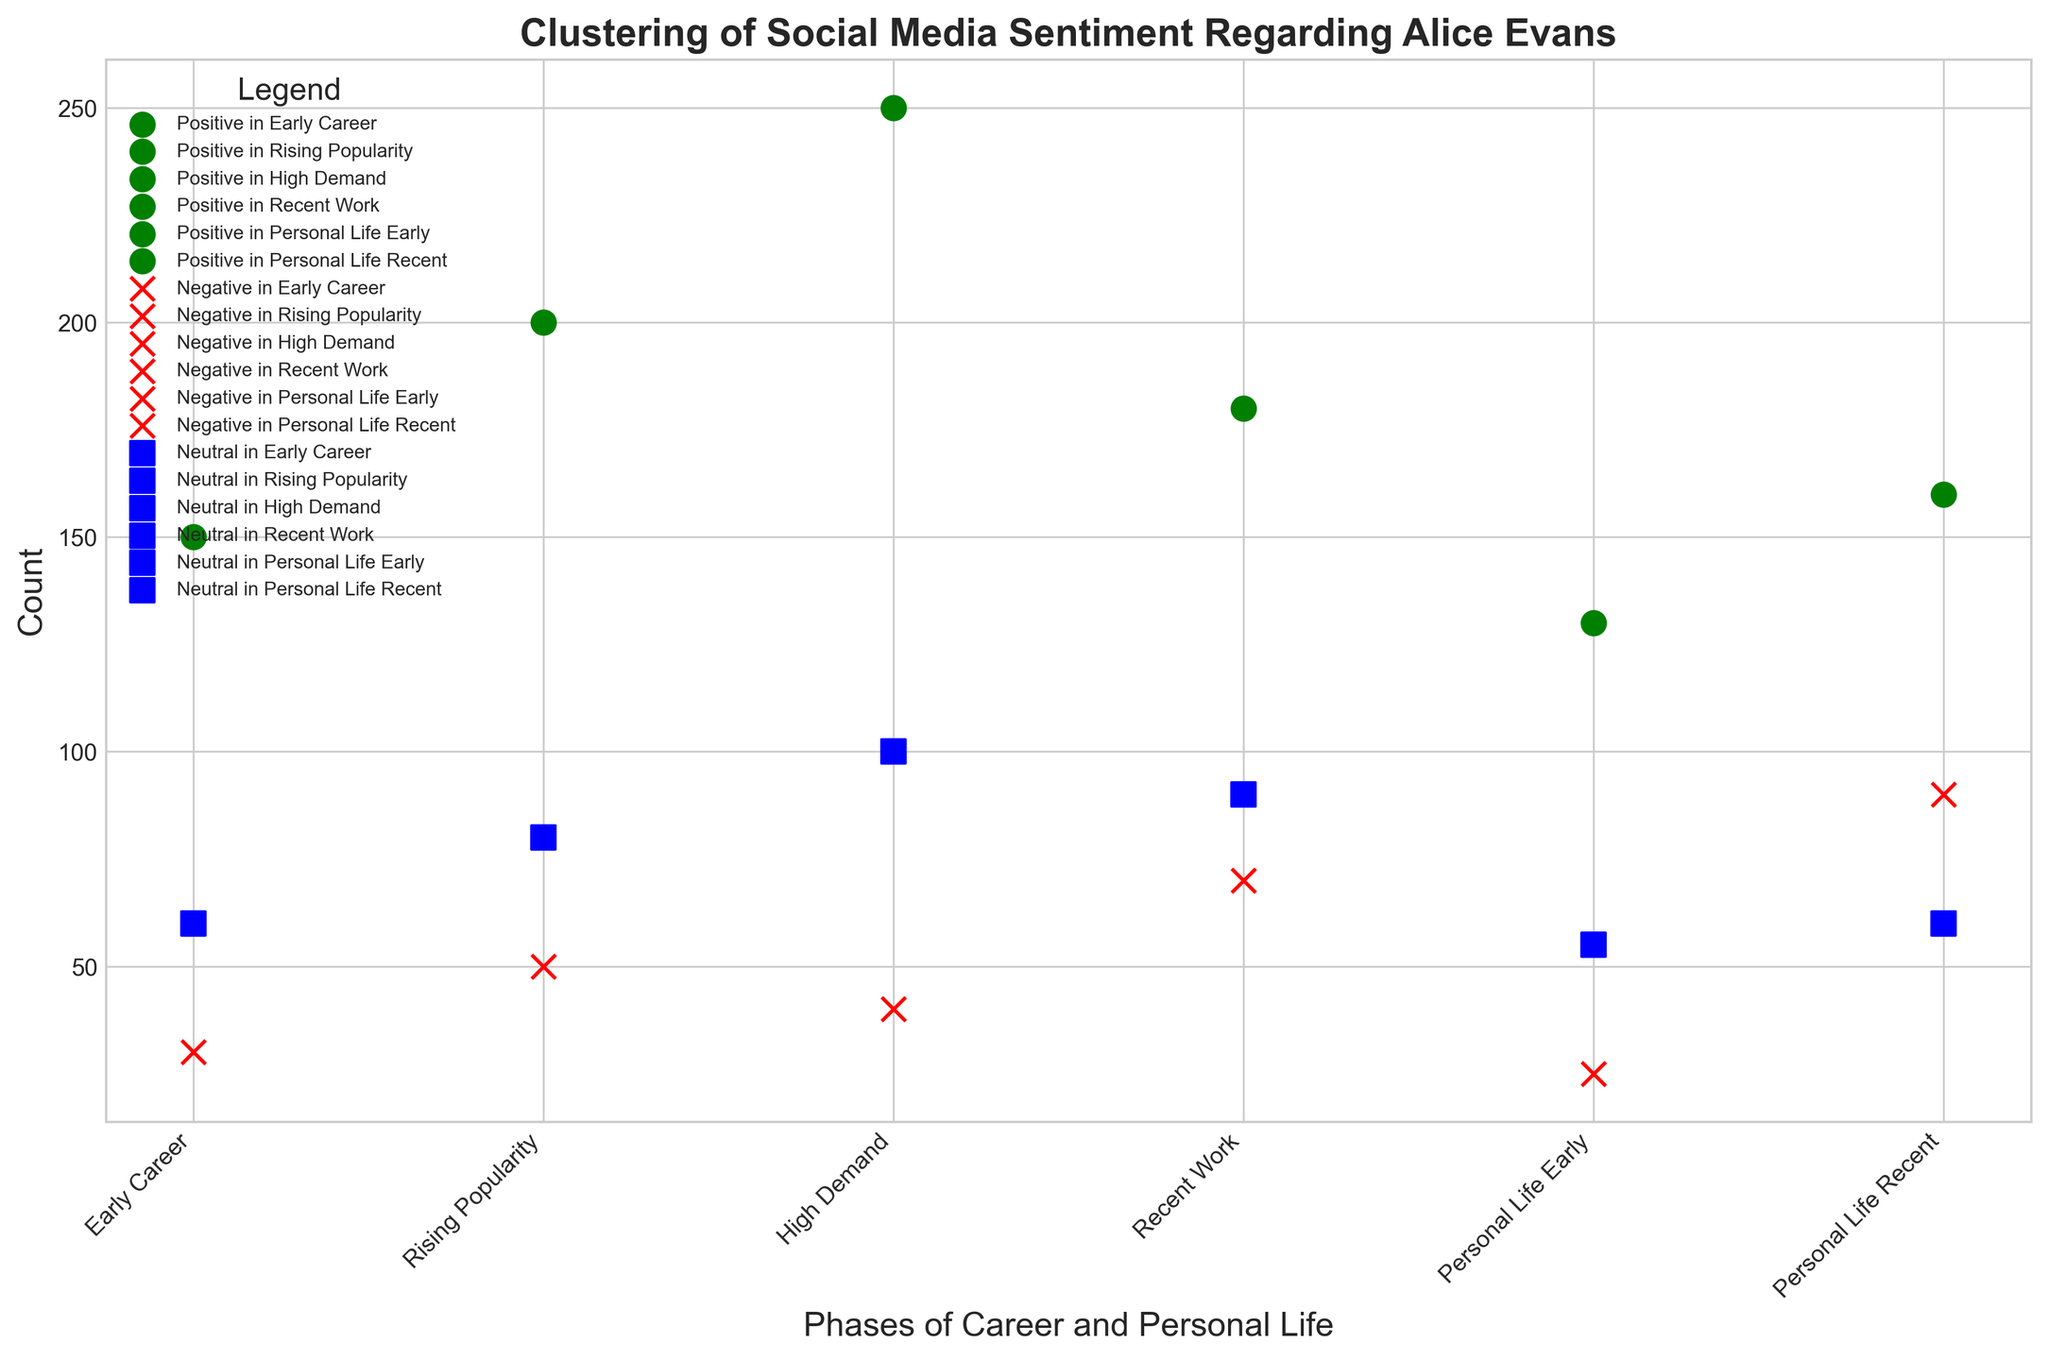What's the overall trend in positive sentiment from Early Career to Recent Work? To answer this, look at the green-colored markers representing positive sentiment from Early Career to Recent Work. The markers increase from 150 in Early Career to 200 in Rising Popularity, peak at 250 in High Demand, and then slightly decrease to 180 in Recent Work. This indicates an initial increase followed by a slight decline.
Answer: Initial increase followed by slight decline Which phase has the highest negative sentiment regarding Alice Evans' professional life? Refer to the red-colored markers for each professional life phase: Early Career (30), Rising Popularity (50), High Demand (40), and Recent Work (70). The highest count is in Recent Work with 70.
Answer: Recent Work In which phase is the neutral sentiment count the lowest overall? Observe the blue-colored markers across all phases. The counts are: Early Career (60), Rising Popularity (80), High Demand (100), Recent Work (90), Personal Life Early (55), Personal Life Recent (60). The lowest count of 55 is in Personal Life Early.
Answer: Personal Life Early What's the difference between positive sentiments in High Demand and Recent Work phases? Positive counts in High Demand and Recent Work are 250 and 180, respectively. Calculate the difference: 250 - 180 = 70.
Answer: 70 What is the average positive sentiment count across all phases? Add all the positive counts: 150 (Early Career) + 200 (Rising Popularity) + 250 (High Demand) + 180 (Recent Work) + 130 (Personal Life Early) + 160 (Personal Life Recent) = 1070. There are 6 phases, so the average is 1070 / 6 ≈ 178.33.
Answer: 178.33 Is the neutral sentiment in Personal Life Recent greater than the neutral sentiment in Personal Life Early? Compare the blue-colored markers: 60 (Personal Life Recent) and 55 (Personal Life Early). 60 is greater than 55.
Answer: Yes During which phase of professional life did Alice Evans have the highest number of neutral sentiments? Check the blue-colored markers for professional life phases: Early Career (60), Rising Popularity (80), High Demand (100), Recent Work (90). The highest count is 100 in High Demand.
Answer: High Demand Which phase saw the most balanced distribution of positive, negative, and neutral sentiments? Balanced distribution implies counts are reasonably close across sentiments. Check the markers: Personal Life Early shows 130 (Positive), 25 (Negative), and 55 (Neutral), which seems more balanced compared to others.
Answer: Personal Life Early How much more positive sentiment was there in Personal Life Recent than in Personal Life Early? Positive sentiment counts are 160 (Personal Life Recent) and 130 (Personal Life Early). Calculate the difference: 160 - 130 = 30.
Answer: 30 What is the ratio of positive to negative sentiments during Rising Popularity? Positive count is 200 and negative count is 50 in Rising Popularity. The ratio is 200 / 50 = 4.
Answer: 4 